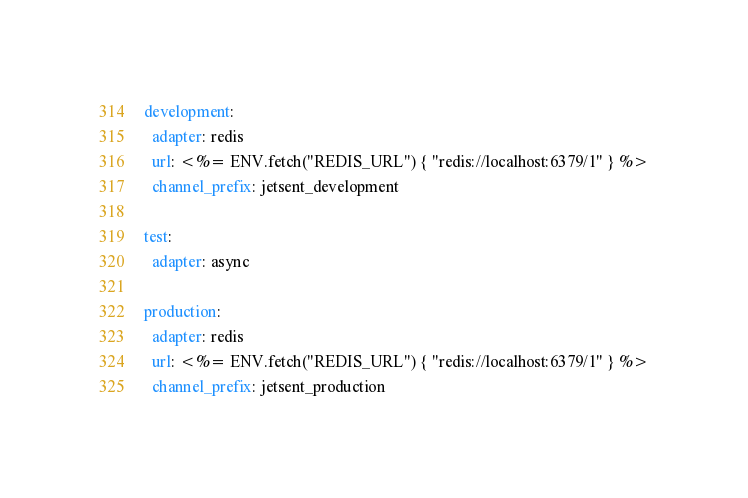<code> <loc_0><loc_0><loc_500><loc_500><_YAML_>development:
  adapter: redis
  url: <%= ENV.fetch("REDIS_URL") { "redis://localhost:6379/1" } %>
  channel_prefix: jetsent_development

test:
  adapter: async

production:
  adapter: redis
  url: <%= ENV.fetch("REDIS_URL") { "redis://localhost:6379/1" } %>
  channel_prefix: jetsent_production
</code> 